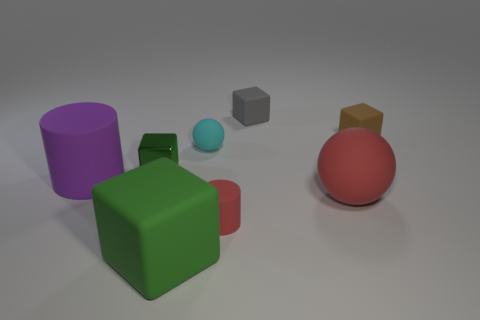What number of other objects are the same color as the tiny sphere?
Offer a very short reply. 0. There is a rubber object that is right of the gray block and to the left of the tiny brown rubber block; what is its color?
Provide a short and direct response. Red. There is a green cube left of the matte block that is in front of the big rubber object on the left side of the tiny green metallic object; how big is it?
Keep it short and to the point. Small. How many objects are blocks that are to the left of the large green rubber cube or small blocks on the right side of the large ball?
Provide a short and direct response. 2. There is a gray object; what shape is it?
Give a very brief answer. Cube. What number of other things are there of the same material as the brown cube
Your answer should be compact. 6. There is another thing that is the same shape as the tiny cyan thing; what is its size?
Your answer should be very brief. Large. There is a small thing that is to the left of the ball that is behind the green block that is on the left side of the large green cube; what is its material?
Keep it short and to the point. Metal. Are there any big purple metal cylinders?
Give a very brief answer. No. There is a shiny block; does it have the same color as the block that is behind the tiny brown rubber block?
Your answer should be very brief. No. 